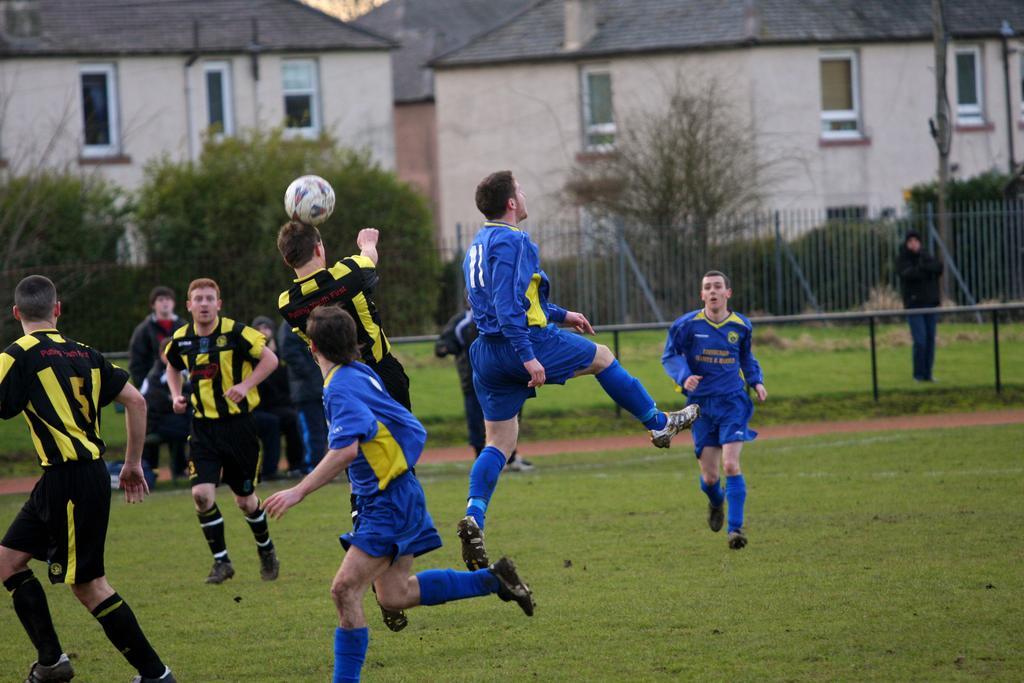Describe this image in one or two sentences. As we can see in he image there is a house, trees, fence and few people playing with ball on ground. 